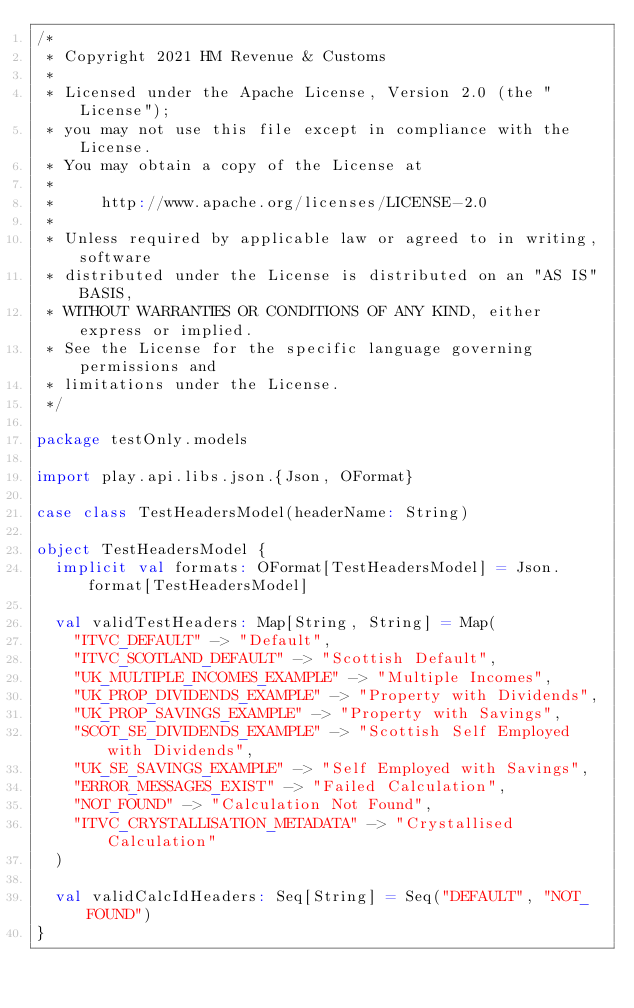Convert code to text. <code><loc_0><loc_0><loc_500><loc_500><_Scala_>/*
 * Copyright 2021 HM Revenue & Customs
 *
 * Licensed under the Apache License, Version 2.0 (the "License");
 * you may not use this file except in compliance with the License.
 * You may obtain a copy of the License at
 *
 *     http://www.apache.org/licenses/LICENSE-2.0
 *
 * Unless required by applicable law or agreed to in writing, software
 * distributed under the License is distributed on an "AS IS" BASIS,
 * WITHOUT WARRANTIES OR CONDITIONS OF ANY KIND, either express or implied.
 * See the License for the specific language governing permissions and
 * limitations under the License.
 */

package testOnly.models

import play.api.libs.json.{Json, OFormat}

case class TestHeadersModel(headerName: String)

object TestHeadersModel {
  implicit val formats: OFormat[TestHeadersModel] = Json.format[TestHeadersModel]

  val validTestHeaders: Map[String, String] = Map(
    "ITVC_DEFAULT" -> "Default",
    "ITVC_SCOTLAND_DEFAULT" -> "Scottish Default",
    "UK_MULTIPLE_INCOMES_EXAMPLE" -> "Multiple Incomes",
    "UK_PROP_DIVIDENDS_EXAMPLE" -> "Property with Dividends",
    "UK_PROP_SAVINGS_EXAMPLE" -> "Property with Savings",
    "SCOT_SE_DIVIDENDS_EXAMPLE" -> "Scottish Self Employed with Dividends",
    "UK_SE_SAVINGS_EXAMPLE" -> "Self Employed with Savings",
    "ERROR_MESSAGES_EXIST" -> "Failed Calculation",
    "NOT_FOUND" -> "Calculation Not Found",
    "ITVC_CRYSTALLISATION_METADATA" -> "Crystallised Calculation"
  )

  val validCalcIdHeaders: Seq[String] = Seq("DEFAULT", "NOT_FOUND")
}
</code> 